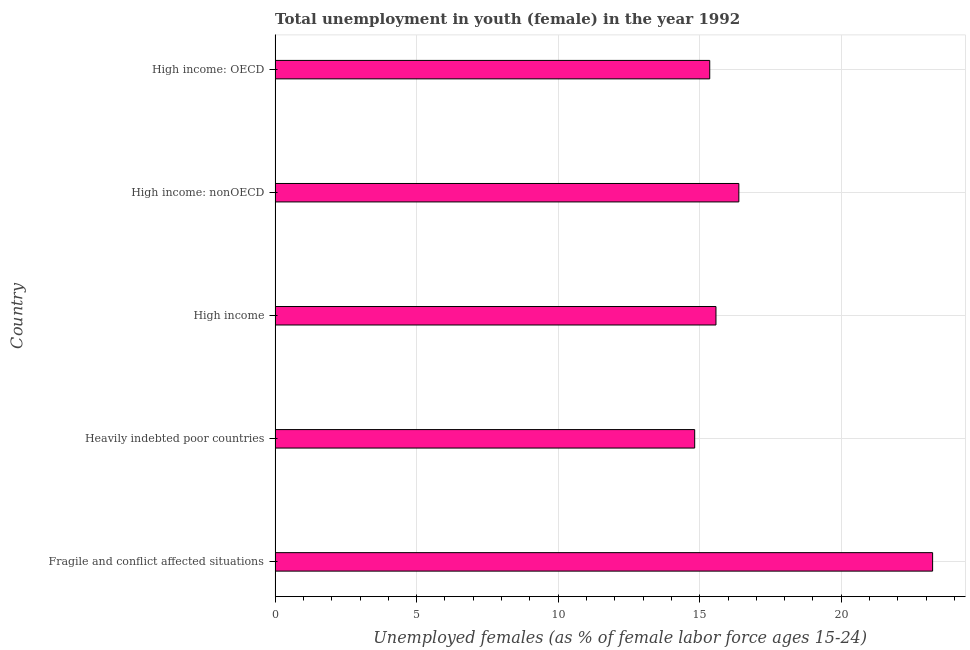What is the title of the graph?
Your answer should be very brief. Total unemployment in youth (female) in the year 1992. What is the label or title of the X-axis?
Offer a very short reply. Unemployed females (as % of female labor force ages 15-24). What is the unemployed female youth population in High income?
Make the answer very short. 15.57. Across all countries, what is the maximum unemployed female youth population?
Keep it short and to the point. 23.23. Across all countries, what is the minimum unemployed female youth population?
Your response must be concise. 14.82. In which country was the unemployed female youth population maximum?
Your answer should be compact. Fragile and conflict affected situations. In which country was the unemployed female youth population minimum?
Ensure brevity in your answer.  Heavily indebted poor countries. What is the sum of the unemployed female youth population?
Make the answer very short. 85.36. What is the difference between the unemployed female youth population in Fragile and conflict affected situations and High income: nonOECD?
Provide a short and direct response. 6.84. What is the average unemployed female youth population per country?
Offer a very short reply. 17.07. What is the median unemployed female youth population?
Provide a short and direct response. 15.57. Is the unemployed female youth population in Heavily indebted poor countries less than that in High income?
Give a very brief answer. Yes. Is the difference between the unemployed female youth population in Fragile and conflict affected situations and High income: OECD greater than the difference between any two countries?
Offer a very short reply. No. What is the difference between the highest and the second highest unemployed female youth population?
Provide a succinct answer. 6.84. How many bars are there?
Your answer should be compact. 5. How many countries are there in the graph?
Make the answer very short. 5. What is the difference between two consecutive major ticks on the X-axis?
Keep it short and to the point. 5. Are the values on the major ticks of X-axis written in scientific E-notation?
Your answer should be very brief. No. What is the Unemployed females (as % of female labor force ages 15-24) in Fragile and conflict affected situations?
Your answer should be very brief. 23.23. What is the Unemployed females (as % of female labor force ages 15-24) in Heavily indebted poor countries?
Your answer should be compact. 14.82. What is the Unemployed females (as % of female labor force ages 15-24) of High income?
Keep it short and to the point. 15.57. What is the Unemployed females (as % of female labor force ages 15-24) of High income: nonOECD?
Offer a very short reply. 16.38. What is the Unemployed females (as % of female labor force ages 15-24) of High income: OECD?
Your answer should be very brief. 15.35. What is the difference between the Unemployed females (as % of female labor force ages 15-24) in Fragile and conflict affected situations and Heavily indebted poor countries?
Your answer should be very brief. 8.4. What is the difference between the Unemployed females (as % of female labor force ages 15-24) in Fragile and conflict affected situations and High income?
Ensure brevity in your answer.  7.65. What is the difference between the Unemployed females (as % of female labor force ages 15-24) in Fragile and conflict affected situations and High income: nonOECD?
Offer a very short reply. 6.84. What is the difference between the Unemployed females (as % of female labor force ages 15-24) in Fragile and conflict affected situations and High income: OECD?
Provide a succinct answer. 7.87. What is the difference between the Unemployed females (as % of female labor force ages 15-24) in Heavily indebted poor countries and High income?
Make the answer very short. -0.75. What is the difference between the Unemployed females (as % of female labor force ages 15-24) in Heavily indebted poor countries and High income: nonOECD?
Ensure brevity in your answer.  -1.56. What is the difference between the Unemployed females (as % of female labor force ages 15-24) in Heavily indebted poor countries and High income: OECD?
Offer a terse response. -0.53. What is the difference between the Unemployed females (as % of female labor force ages 15-24) in High income and High income: nonOECD?
Make the answer very short. -0.81. What is the difference between the Unemployed females (as % of female labor force ages 15-24) in High income and High income: OECD?
Keep it short and to the point. 0.22. What is the difference between the Unemployed females (as % of female labor force ages 15-24) in High income: nonOECD and High income: OECD?
Your answer should be compact. 1.03. What is the ratio of the Unemployed females (as % of female labor force ages 15-24) in Fragile and conflict affected situations to that in Heavily indebted poor countries?
Offer a terse response. 1.57. What is the ratio of the Unemployed females (as % of female labor force ages 15-24) in Fragile and conflict affected situations to that in High income?
Give a very brief answer. 1.49. What is the ratio of the Unemployed females (as % of female labor force ages 15-24) in Fragile and conflict affected situations to that in High income: nonOECD?
Your answer should be compact. 1.42. What is the ratio of the Unemployed females (as % of female labor force ages 15-24) in Fragile and conflict affected situations to that in High income: OECD?
Your response must be concise. 1.51. What is the ratio of the Unemployed females (as % of female labor force ages 15-24) in Heavily indebted poor countries to that in High income: nonOECD?
Your response must be concise. 0.91. What is the ratio of the Unemployed females (as % of female labor force ages 15-24) in Heavily indebted poor countries to that in High income: OECD?
Provide a short and direct response. 0.96. What is the ratio of the Unemployed females (as % of female labor force ages 15-24) in High income to that in High income: nonOECD?
Offer a terse response. 0.95. What is the ratio of the Unemployed females (as % of female labor force ages 15-24) in High income: nonOECD to that in High income: OECD?
Provide a short and direct response. 1.07. 